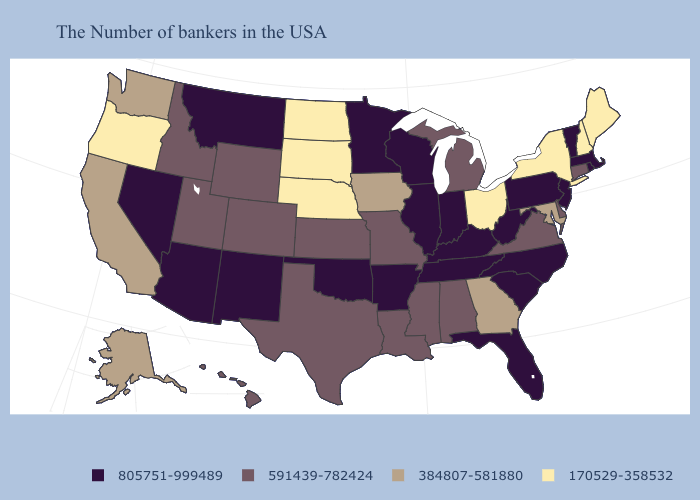Name the states that have a value in the range 805751-999489?
Keep it brief. Massachusetts, Rhode Island, Vermont, New Jersey, Pennsylvania, North Carolina, South Carolina, West Virginia, Florida, Kentucky, Indiana, Tennessee, Wisconsin, Illinois, Arkansas, Minnesota, Oklahoma, New Mexico, Montana, Arizona, Nevada. Name the states that have a value in the range 805751-999489?
Short answer required. Massachusetts, Rhode Island, Vermont, New Jersey, Pennsylvania, North Carolina, South Carolina, West Virginia, Florida, Kentucky, Indiana, Tennessee, Wisconsin, Illinois, Arkansas, Minnesota, Oklahoma, New Mexico, Montana, Arizona, Nevada. Which states have the lowest value in the USA?
Be succinct. Maine, New Hampshire, New York, Ohio, Nebraska, South Dakota, North Dakota, Oregon. What is the lowest value in states that border Missouri?
Keep it brief. 170529-358532. Name the states that have a value in the range 170529-358532?
Quick response, please. Maine, New Hampshire, New York, Ohio, Nebraska, South Dakota, North Dakota, Oregon. What is the value of Tennessee?
Answer briefly. 805751-999489. What is the lowest value in the West?
Quick response, please. 170529-358532. Does the first symbol in the legend represent the smallest category?
Answer briefly. No. Does Washington have the lowest value in the West?
Short answer required. No. Which states have the highest value in the USA?
Answer briefly. Massachusetts, Rhode Island, Vermont, New Jersey, Pennsylvania, North Carolina, South Carolina, West Virginia, Florida, Kentucky, Indiana, Tennessee, Wisconsin, Illinois, Arkansas, Minnesota, Oklahoma, New Mexico, Montana, Arizona, Nevada. Does the first symbol in the legend represent the smallest category?
Quick response, please. No. What is the value of Nebraska?
Write a very short answer. 170529-358532. Which states hav the highest value in the MidWest?
Quick response, please. Indiana, Wisconsin, Illinois, Minnesota. 